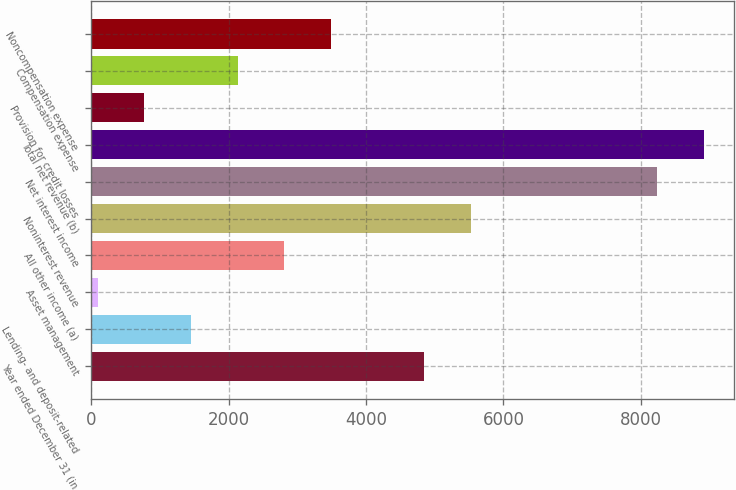<chart> <loc_0><loc_0><loc_500><loc_500><bar_chart><fcel>Year ended December 31 (in<fcel>Lending- and deposit-related<fcel>Asset management<fcel>All other income (a)<fcel>Noninterest revenue<fcel>Net interest income<fcel>Total net revenue (b)<fcel>Provision for credit losses<fcel>Compensation expense<fcel>Noncompensation expense<nl><fcel>4845<fcel>1450<fcel>92<fcel>2808<fcel>5524<fcel>8240<fcel>8919<fcel>771<fcel>2129<fcel>3487<nl></chart> 